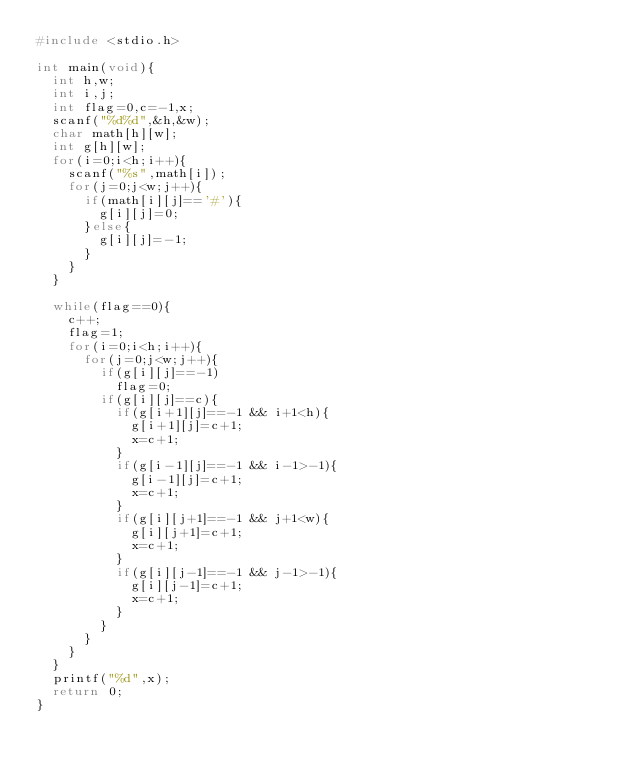<code> <loc_0><loc_0><loc_500><loc_500><_C_>#include <stdio.h>

int main(void){
  int h,w;
  int i,j;
  int flag=0,c=-1,x;
  scanf("%d%d",&h,&w);
  char math[h][w];
  int g[h][w];
  for(i=0;i<h;i++){
    scanf("%s",math[i]);
    for(j=0;j<w;j++){
      if(math[i][j]=='#'){
        g[i][j]=0;
      }else{
        g[i][j]=-1;
      }
    }
  }
  
  while(flag==0){
    c++;
    flag=1;
    for(i=0;i<h;i++){
      for(j=0;j<w;j++){
        if(g[i][j]==-1)
          flag=0;
        if(g[i][j]==c){
          if(g[i+1][j]==-1 && i+1<h){
            g[i+1][j]=c+1;
            x=c+1;
          }
          if(g[i-1][j]==-1 && i-1>-1){
            g[i-1][j]=c+1;
            x=c+1;
          }
          if(g[i][j+1]==-1 && j+1<w){
            g[i][j+1]=c+1;
            x=c+1;
          }
          if(g[i][j-1]==-1 && j-1>-1){
            g[i][j-1]=c+1;
            x=c+1;
          }
        }
      }
    }
  }
  printf("%d",x);
  return 0;
}</code> 